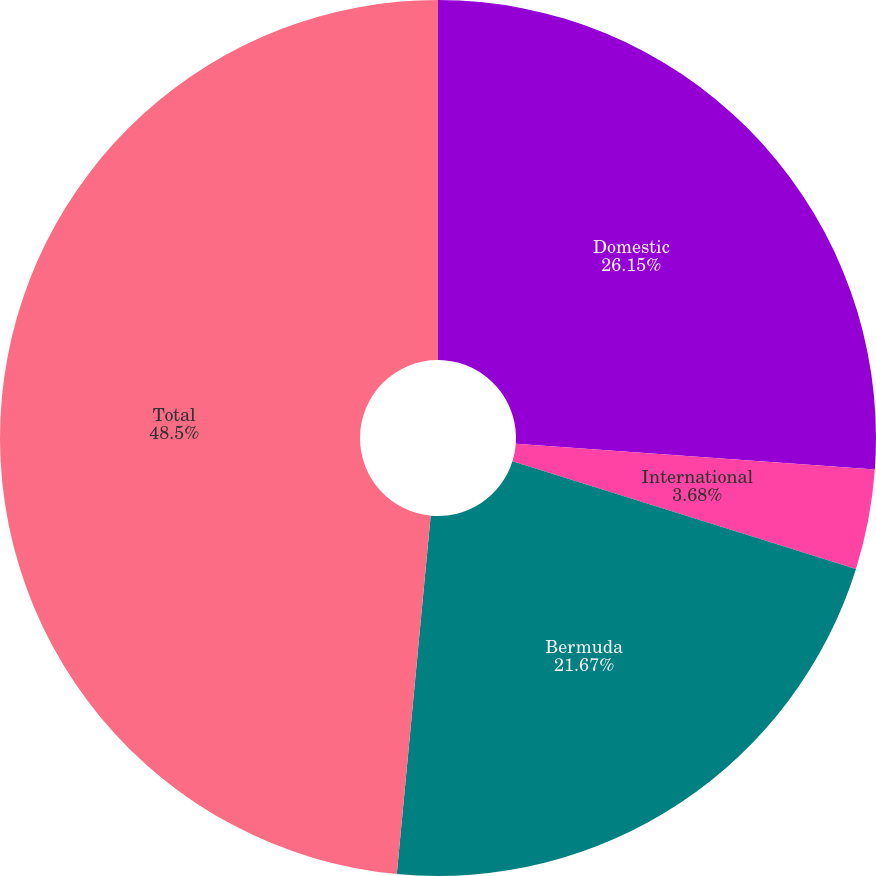Convert chart. <chart><loc_0><loc_0><loc_500><loc_500><pie_chart><fcel>Domestic<fcel>International<fcel>Bermuda<fcel>Total<nl><fcel>26.15%<fcel>3.68%<fcel>21.67%<fcel>48.5%<nl></chart> 